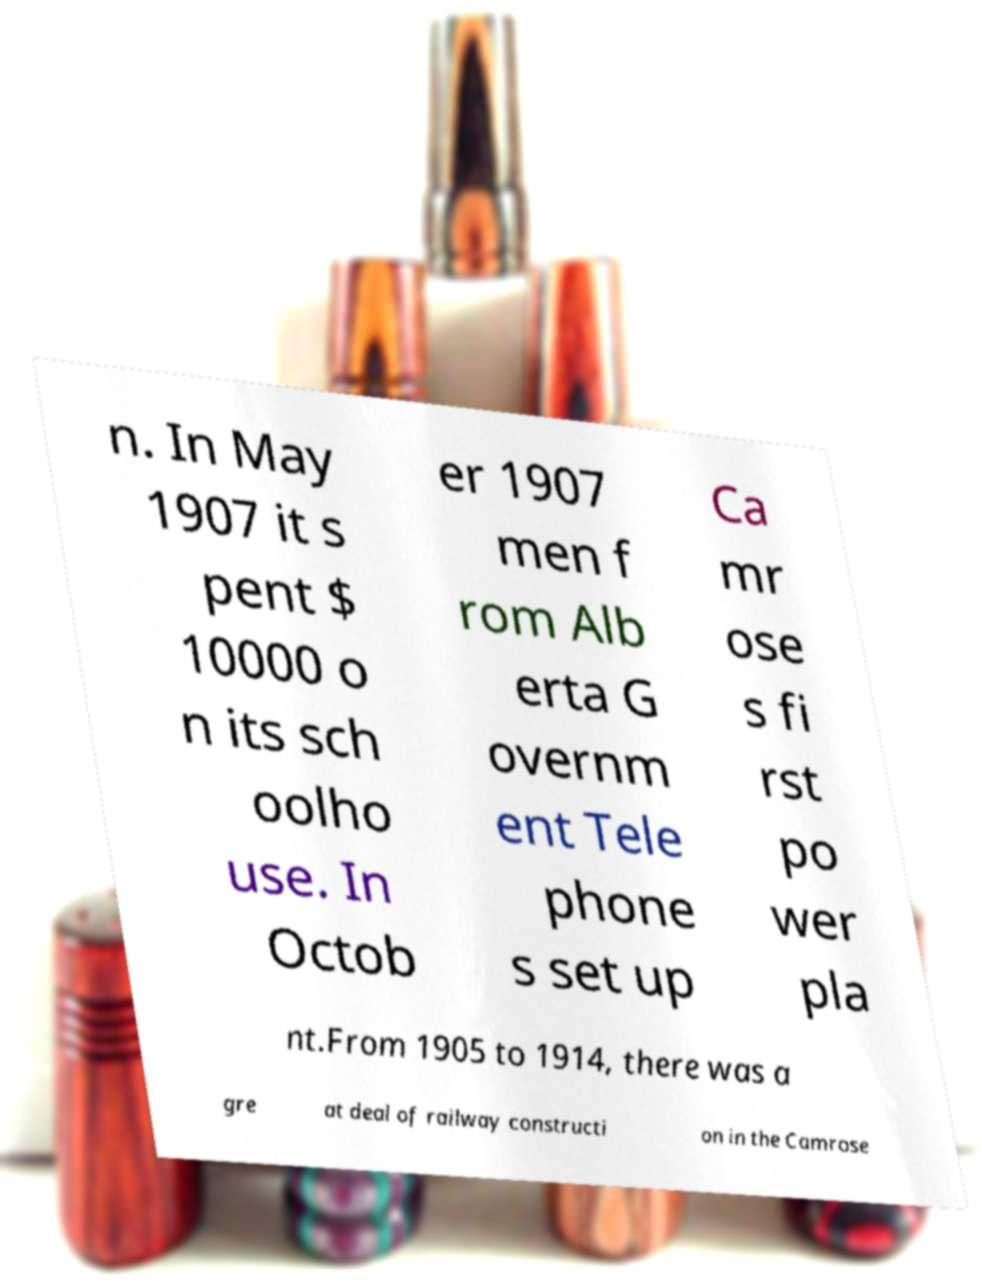For documentation purposes, I need the text within this image transcribed. Could you provide that? n. In May 1907 it s pent $ 10000 o n its sch oolho use. In Octob er 1907 men f rom Alb erta G overnm ent Tele phone s set up Ca mr ose s fi rst po wer pla nt.From 1905 to 1914, there was a gre at deal of railway constructi on in the Camrose 